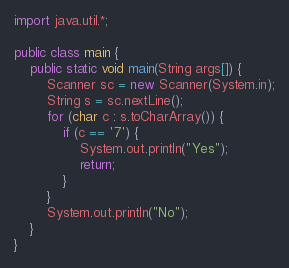Convert code to text. <code><loc_0><loc_0><loc_500><loc_500><_Java_>import java.util.*;

public class main {
	public static void main(String args[]) {
    	Scanner sc = new Scanner(System.in);
        String s = sc.nextLine();
      	for (char c : s.toCharArray()) {
        	if (c == '7') {
            	System.out.println("Yes");
                return;
            }
        }
        System.out.println("No");
    }
}</code> 